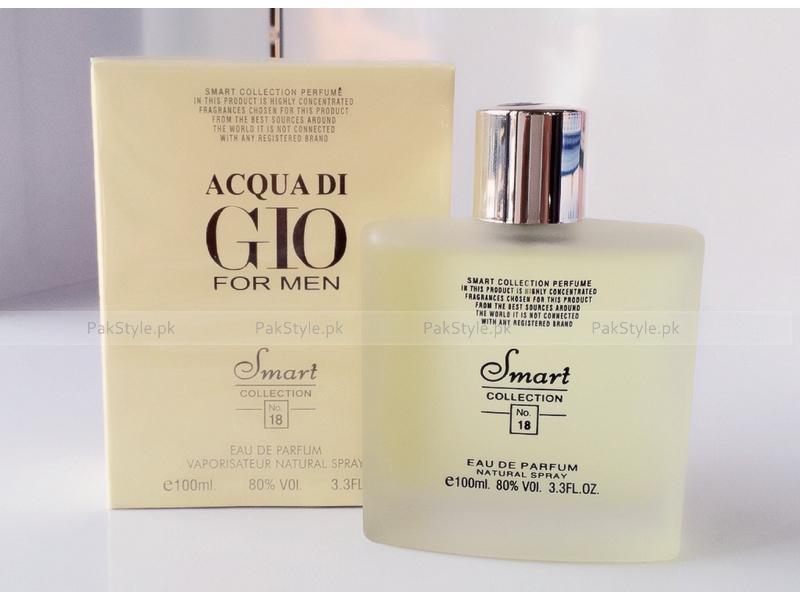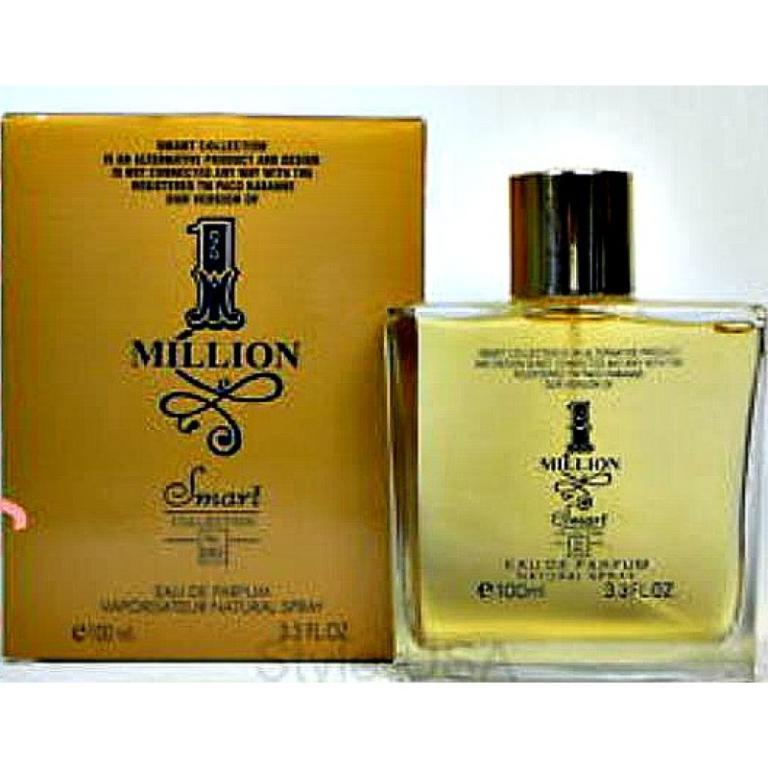The first image is the image on the left, the second image is the image on the right. Considering the images on both sides, is "The  glass perfume bottle furthest to the right in the right image is purple." valid? Answer yes or no. No. 